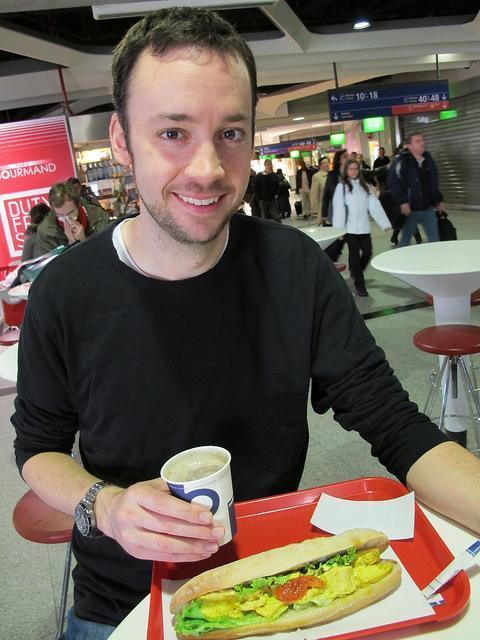How many people can be seen?
Give a very brief answer. 4. How many dining tables can be seen?
Give a very brief answer. 2. How many laptops are there on the table?
Give a very brief answer. 0. 